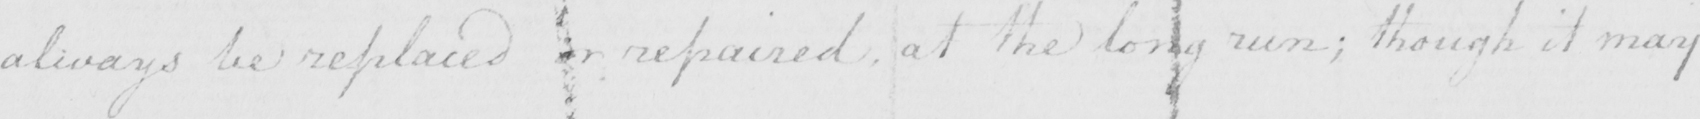Can you read and transcribe this handwriting? always be replaced or repaired at the long run ; though it may 